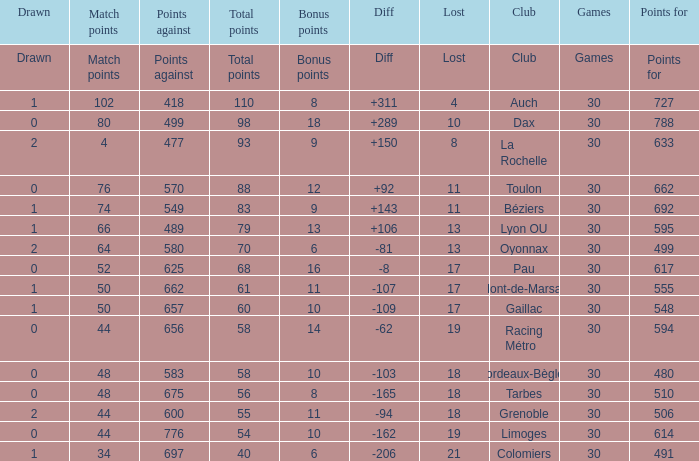How many bonus points did the Colomiers earn? 6.0. 